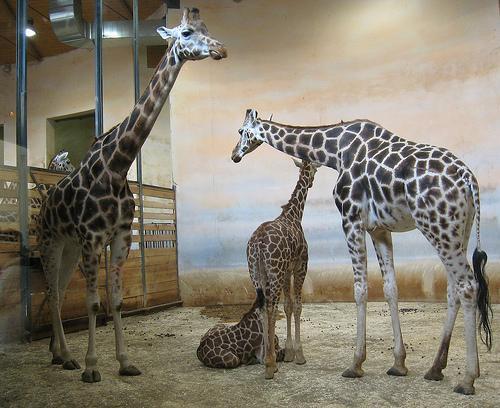How many giraffes are sitting?
Give a very brief answer. 1. 